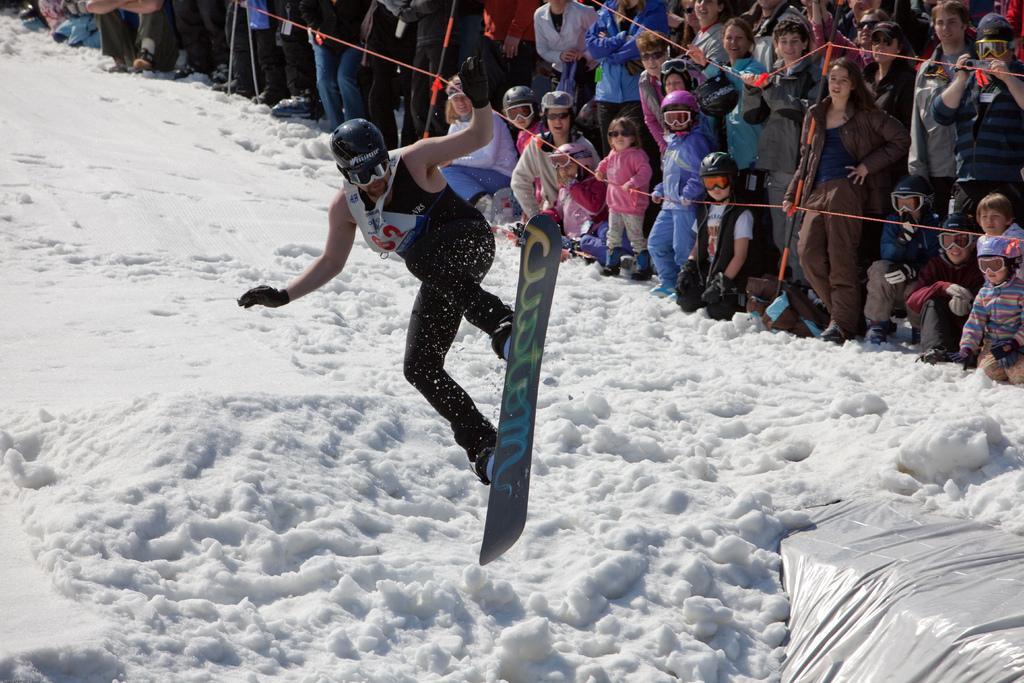In one or two sentences, can you explain what this image depicts? In the image we can see there is a ground covered with snow and there is a person standing on the skateboard in the air. He is wearing goggles and helmet. Behind there are spectators standing and they are watching the person. There are few people wearing helmet and goggles. 